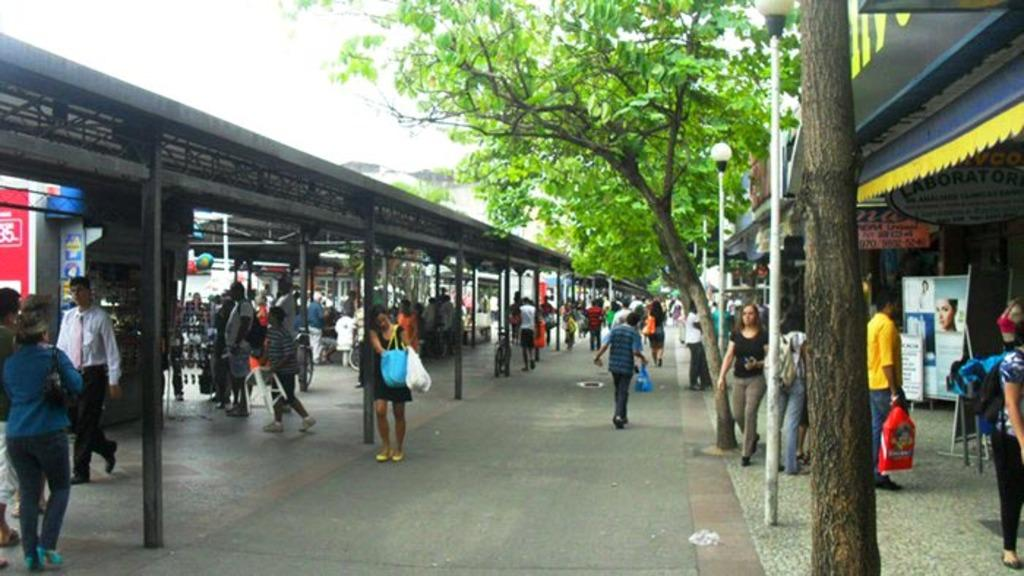What are the people in the image doing? The people in the image are walking. What type of vegetation is on the right side of the image? There are trees on the right side of the image. What structure is located on the left side of the image? There is a shed on the left side of the image. What is visible at the top of the image? The sky is visible at the top of the image. What type of business is being conducted by the team in the image? There is no team or business present in the image; it features people walking and a shed on the left side. How many legs can be seen on the people in the image? The question about the number of legs is irrelevant, as the focus should be on the visible subjects and objects in the image, not the individual body parts of the people. 